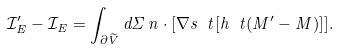<formula> <loc_0><loc_0><loc_500><loc_500>\mathcal { I } ^ { \prime } _ { E } - \mathcal { I } _ { E } = \int _ { \partial \widetilde { V } } d \Sigma \, n \cdot [ \nabla s \ t [ h \ t ( M ^ { \prime } - M ) ] ] .</formula> 